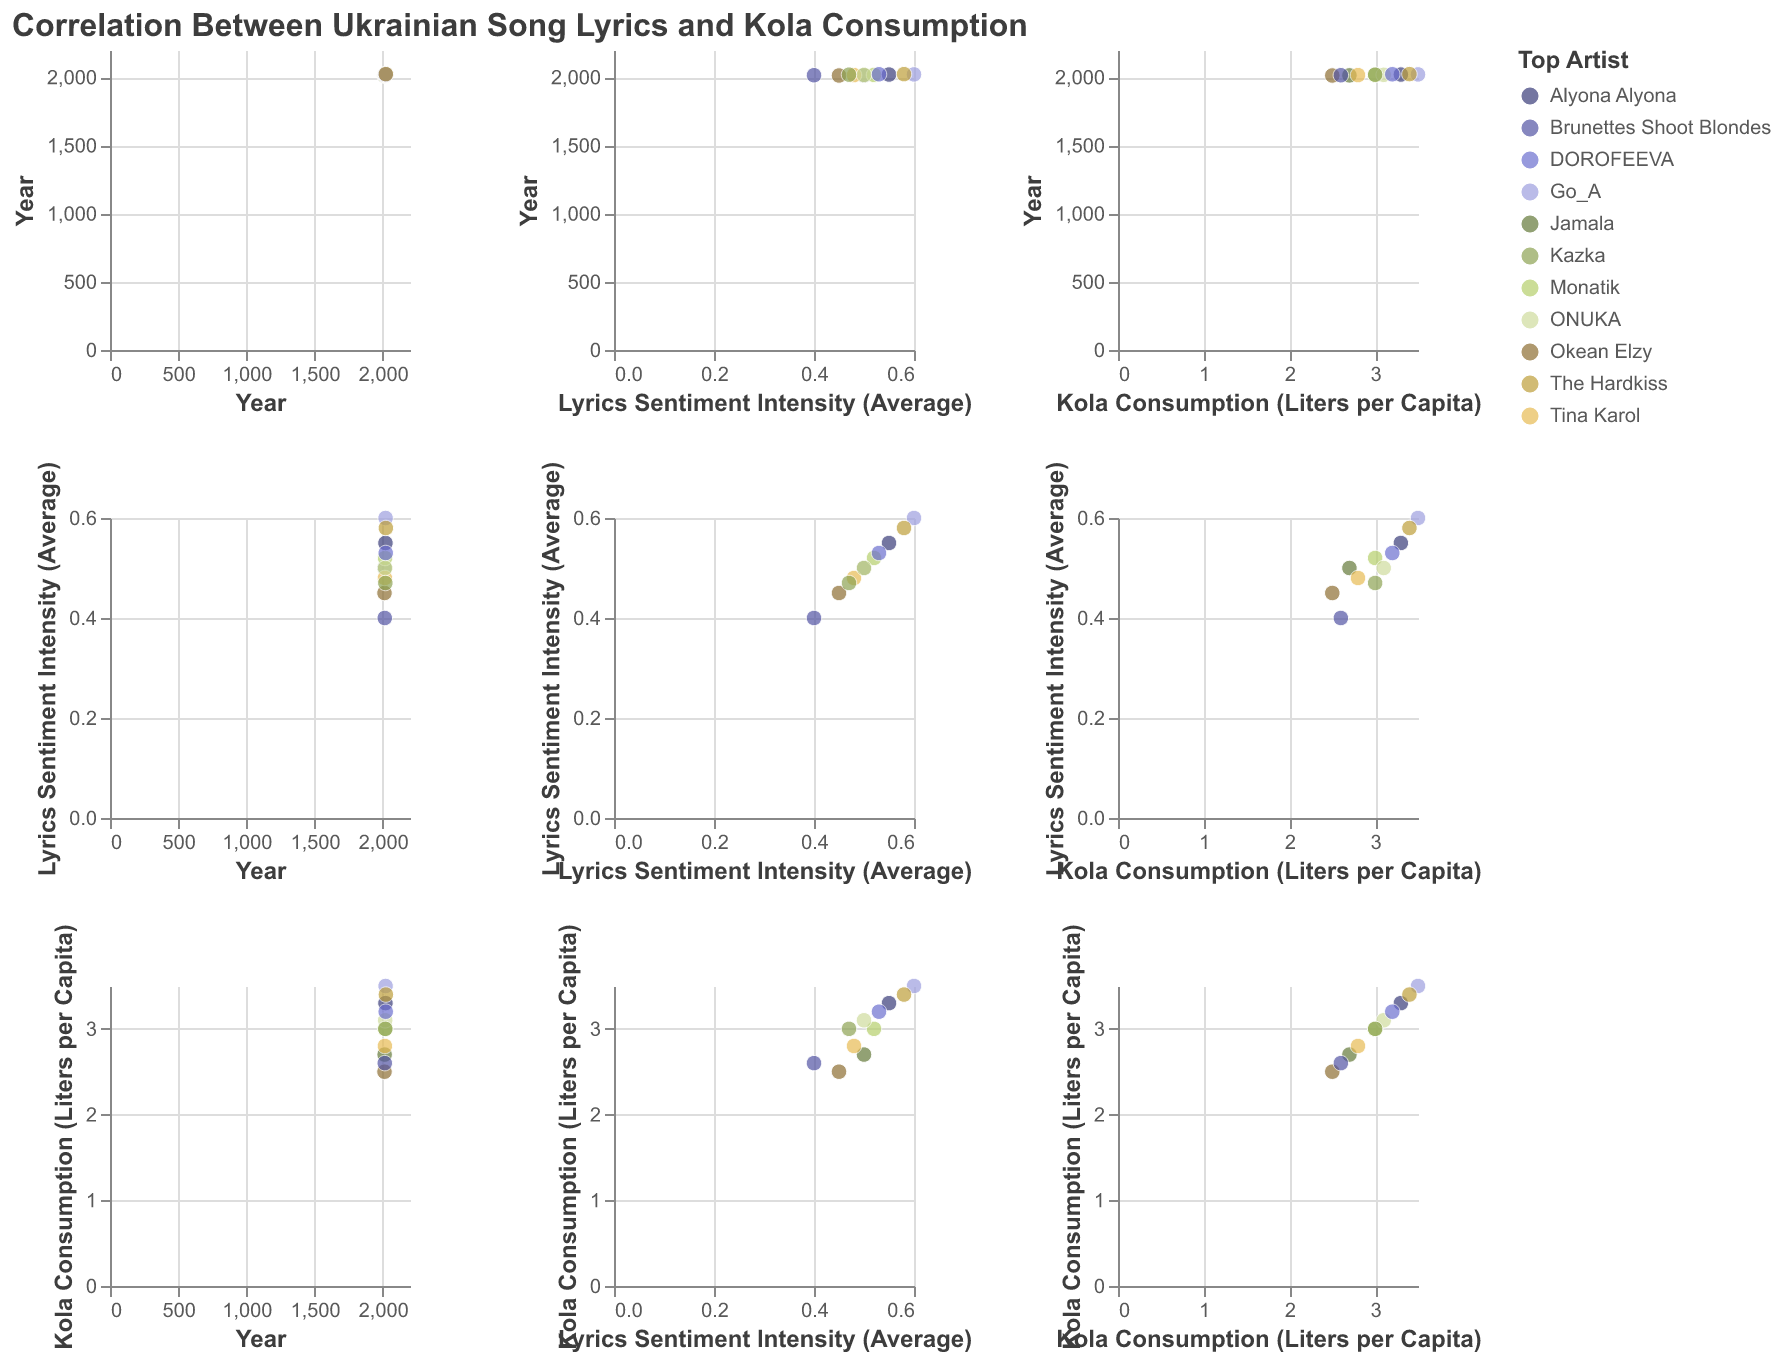What is the title of the figure? The title of a figure is usually displayed at the top and provides a summary of what the plot represents. In this case, it is "Correlation Between Ukrainian Song Lyrics and Kola Consumption".
Answer: Correlation Between Ukrainian Song Lyrics and Kola Consumption How many variables are displayed in the scatter plot matrix? In a scatter plot matrix, each row and column represent a different variable. The variables here are "Year", "Lyrics Sentiment Intensity (Average)", and "Kola Consumption (Liters per Capita)".
Answer: 3 Which artist appears most frequently in the scatter plot matrix? By examining the color codes or tooltips for each data point in the matrix, we can determine that each year has a different top song and artist, showing no artist appears more than once.
Answer: Each artist appears once What is the relationship trend between Lyrics Sentiment Intensity and Kola Consumption over the years? Look at the scatter plots where "Lyrics Sentiment Intensity (Average)" is on one axis and "Kola Consumption (Liters per Capita)" on the other. Generally, as the sentiment intensity increases, kola consumption also increases.
Answer: Positive correlation In which year did Lyrics Sentiment Intensity peak, and what was the Kola Consumption that year? Find the highest point in the scatter plot corresponding to "Lyrics Sentiment Intensity (Average)" and find the corresponding year and "Kola Consumption (Liters per Capita)" in the same plot or using tooltips. The peak intensity of 0.60 occurs in 2021, with kola consumption at 3.5 liters per capita.
Answer: 2021, 3.5 liters What was the lowest Lyrics Sentiment Intensity and its corresponding song title? Locate the data point with the smallest value of "Lyrics Sentiment Intensity (Average)" and check its tooltip or respective scatter in the matrix. The lowest sentiment intensity was 0.40 in 2015 for "1986" by Brunettes Shoot Blondes.
Answer: 2015, 1986 by Brunettes Shoot Blondes Is there any year where Kola Consumption remained constant despite changes in Lyrics Sentiment Intensity? Look for vertical or horizontal lines in scatter plots involving these two variables, representing constant cola consumption despite varying sentiment intensities. For example, in 2017 and 2019, the cola consumption is 3.0 liters, but the sentiment intensities are 0.52 and 0.47 respectively.
Answer: 2017 and 2019 Which year had the highest Kola Consumption and what was the Lyrics Sentiment Intensity for that year? Find the maximum value on the "Kola Consumption (Liters per Capita)" axis and locate the corresponding data point to determine the year and lyrics sentiment intensity. The highest consumption was 3.5 liters per capita in 2021 with a sentiment intensity of 0.60.
Answer: 2021, 0.60 Are there any outliers in the relationship between lyrics sentiment and Kola consumption trends? Identify points that do not follow the general trend in scatter plots, such as a data point far from the main cluster of points. The point for 2015 with sentiment intensity 0.40 and kola consumption 2.6 liters might be considered an outlier as it deviates from the positive correlation trend.
Answer: 2015 